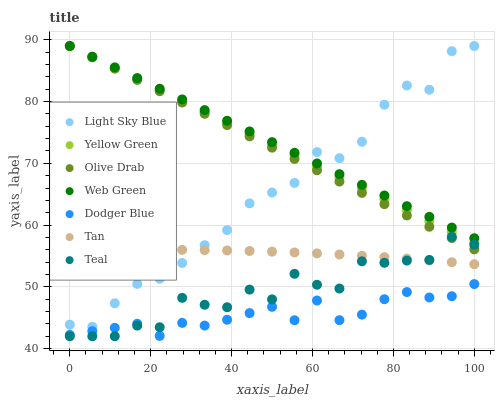Does Dodger Blue have the minimum area under the curve?
Answer yes or no. Yes. Does Web Green have the maximum area under the curve?
Answer yes or no. Yes. Does Light Sky Blue have the minimum area under the curve?
Answer yes or no. No. Does Light Sky Blue have the maximum area under the curve?
Answer yes or no. No. Is Olive Drab the smoothest?
Answer yes or no. Yes. Is Teal the roughest?
Answer yes or no. Yes. Is Web Green the smoothest?
Answer yes or no. No. Is Web Green the roughest?
Answer yes or no. No. Does Teal have the lowest value?
Answer yes or no. Yes. Does Light Sky Blue have the lowest value?
Answer yes or no. No. Does Olive Drab have the highest value?
Answer yes or no. Yes. Does Dodger Blue have the highest value?
Answer yes or no. No. Is Teal less than Light Sky Blue?
Answer yes or no. Yes. Is Web Green greater than Dodger Blue?
Answer yes or no. Yes. Does Light Sky Blue intersect Web Green?
Answer yes or no. Yes. Is Light Sky Blue less than Web Green?
Answer yes or no. No. Is Light Sky Blue greater than Web Green?
Answer yes or no. No. Does Teal intersect Light Sky Blue?
Answer yes or no. No. 